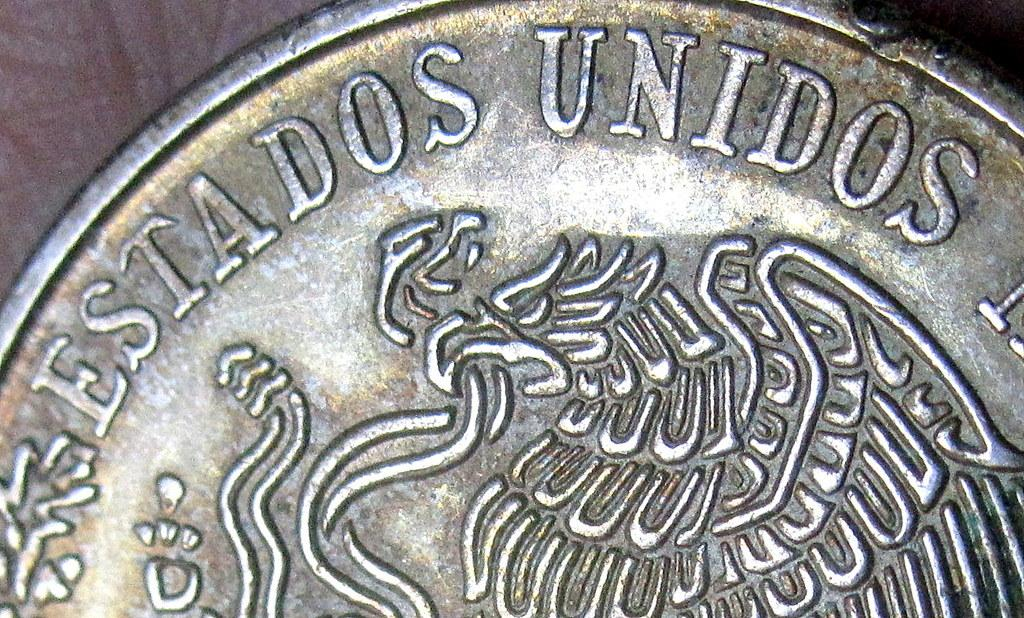Provide a one-sentence caption for the provided image. coin with the words Estados Unidos printed on the side. 